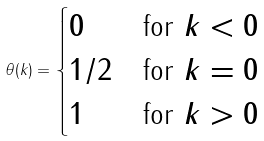Convert formula to latex. <formula><loc_0><loc_0><loc_500><loc_500>\theta ( k ) = \begin{cases} 0 & \text {for $k<0$} \\ 1 / 2 & \text {for $k=0$} \\ 1 & \text {for $k>0$} \end{cases}</formula> 